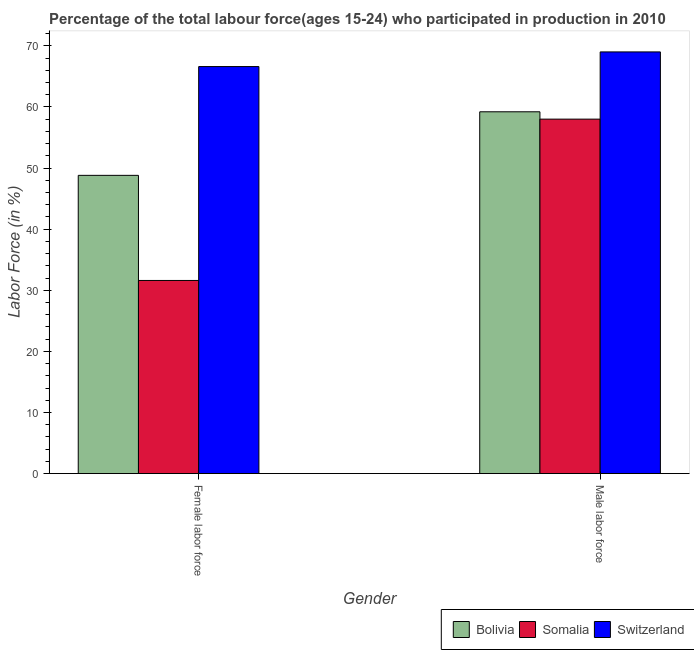Are the number of bars on each tick of the X-axis equal?
Keep it short and to the point. Yes. How many bars are there on the 2nd tick from the right?
Provide a short and direct response. 3. What is the label of the 1st group of bars from the left?
Offer a terse response. Female labor force. What is the percentage of male labour force in Bolivia?
Offer a terse response. 59.2. In which country was the percentage of male labour force maximum?
Offer a terse response. Switzerland. In which country was the percentage of female labor force minimum?
Your response must be concise. Somalia. What is the total percentage of female labor force in the graph?
Give a very brief answer. 147. What is the difference between the percentage of male labour force in Somalia and that in Switzerland?
Make the answer very short. -11. What is the difference between the percentage of male labour force in Somalia and the percentage of female labor force in Bolivia?
Ensure brevity in your answer.  9.2. What is the average percentage of male labour force per country?
Provide a succinct answer. 62.07. What is the difference between the percentage of male labour force and percentage of female labor force in Bolivia?
Provide a succinct answer. 10.4. In how many countries, is the percentage of male labour force greater than 50 %?
Your response must be concise. 3. What is the ratio of the percentage of female labor force in Bolivia to that in Switzerland?
Your answer should be very brief. 0.73. Is the percentage of female labor force in Switzerland less than that in Somalia?
Your answer should be compact. No. In how many countries, is the percentage of female labor force greater than the average percentage of female labor force taken over all countries?
Provide a short and direct response. 1. What does the 3rd bar from the left in Female labor force represents?
Give a very brief answer. Switzerland. What does the 1st bar from the right in Female labor force represents?
Your answer should be compact. Switzerland. How many bars are there?
Give a very brief answer. 6. Does the graph contain any zero values?
Your response must be concise. No. Where does the legend appear in the graph?
Offer a very short reply. Bottom right. How many legend labels are there?
Keep it short and to the point. 3. What is the title of the graph?
Your answer should be very brief. Percentage of the total labour force(ages 15-24) who participated in production in 2010. What is the label or title of the X-axis?
Keep it short and to the point. Gender. What is the Labor Force (in %) of Bolivia in Female labor force?
Offer a terse response. 48.8. What is the Labor Force (in %) in Somalia in Female labor force?
Provide a succinct answer. 31.6. What is the Labor Force (in %) in Switzerland in Female labor force?
Offer a terse response. 66.6. What is the Labor Force (in %) of Bolivia in Male labor force?
Your response must be concise. 59.2. Across all Gender, what is the maximum Labor Force (in %) in Bolivia?
Give a very brief answer. 59.2. Across all Gender, what is the maximum Labor Force (in %) of Somalia?
Give a very brief answer. 58. Across all Gender, what is the maximum Labor Force (in %) of Switzerland?
Provide a succinct answer. 69. Across all Gender, what is the minimum Labor Force (in %) in Bolivia?
Offer a terse response. 48.8. Across all Gender, what is the minimum Labor Force (in %) in Somalia?
Offer a very short reply. 31.6. Across all Gender, what is the minimum Labor Force (in %) of Switzerland?
Your answer should be very brief. 66.6. What is the total Labor Force (in %) in Bolivia in the graph?
Give a very brief answer. 108. What is the total Labor Force (in %) of Somalia in the graph?
Ensure brevity in your answer.  89.6. What is the total Labor Force (in %) in Switzerland in the graph?
Your answer should be very brief. 135.6. What is the difference between the Labor Force (in %) of Somalia in Female labor force and that in Male labor force?
Your answer should be compact. -26.4. What is the difference between the Labor Force (in %) in Switzerland in Female labor force and that in Male labor force?
Provide a succinct answer. -2.4. What is the difference between the Labor Force (in %) of Bolivia in Female labor force and the Labor Force (in %) of Switzerland in Male labor force?
Provide a succinct answer. -20.2. What is the difference between the Labor Force (in %) in Somalia in Female labor force and the Labor Force (in %) in Switzerland in Male labor force?
Your answer should be compact. -37.4. What is the average Labor Force (in %) of Somalia per Gender?
Your answer should be compact. 44.8. What is the average Labor Force (in %) in Switzerland per Gender?
Provide a short and direct response. 67.8. What is the difference between the Labor Force (in %) in Bolivia and Labor Force (in %) in Switzerland in Female labor force?
Give a very brief answer. -17.8. What is the difference between the Labor Force (in %) in Somalia and Labor Force (in %) in Switzerland in Female labor force?
Offer a terse response. -35. What is the difference between the Labor Force (in %) of Bolivia and Labor Force (in %) of Somalia in Male labor force?
Ensure brevity in your answer.  1.2. What is the difference between the Labor Force (in %) in Bolivia and Labor Force (in %) in Switzerland in Male labor force?
Your response must be concise. -9.8. What is the difference between the Labor Force (in %) of Somalia and Labor Force (in %) of Switzerland in Male labor force?
Provide a short and direct response. -11. What is the ratio of the Labor Force (in %) in Bolivia in Female labor force to that in Male labor force?
Provide a short and direct response. 0.82. What is the ratio of the Labor Force (in %) in Somalia in Female labor force to that in Male labor force?
Your answer should be very brief. 0.54. What is the ratio of the Labor Force (in %) of Switzerland in Female labor force to that in Male labor force?
Make the answer very short. 0.97. What is the difference between the highest and the second highest Labor Force (in %) of Bolivia?
Your response must be concise. 10.4. What is the difference between the highest and the second highest Labor Force (in %) in Somalia?
Ensure brevity in your answer.  26.4. What is the difference between the highest and the second highest Labor Force (in %) of Switzerland?
Ensure brevity in your answer.  2.4. What is the difference between the highest and the lowest Labor Force (in %) in Somalia?
Your answer should be compact. 26.4. 